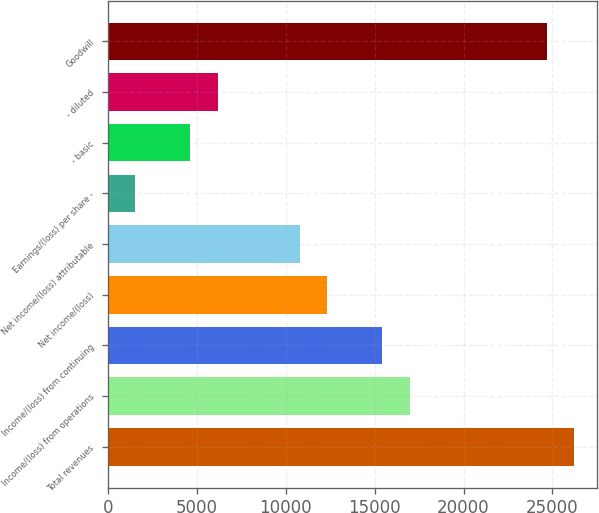Convert chart. <chart><loc_0><loc_0><loc_500><loc_500><bar_chart><fcel>Total revenues<fcel>Income/(loss) from operations<fcel>Income/(loss) from continuing<fcel>Net income/(loss)<fcel>Net income/(loss) attributable<fcel>Earnings/(loss) per share -<fcel>- basic<fcel>- diluted<fcel>Goodwill<nl><fcel>26213.4<fcel>16962.8<fcel>15421<fcel>12337.4<fcel>10795.6<fcel>1544.96<fcel>4628.52<fcel>6170.3<fcel>24671.7<nl></chart> 